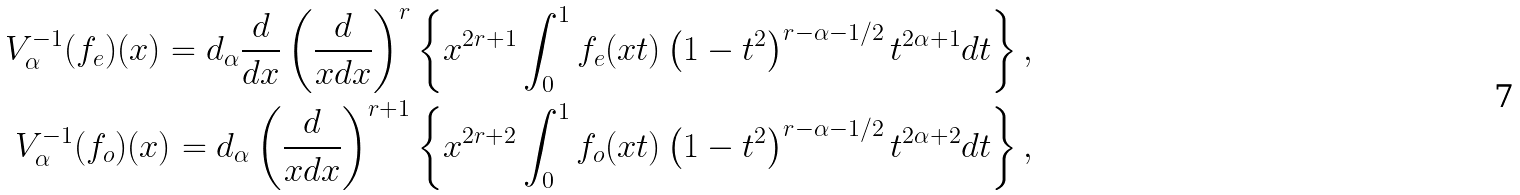<formula> <loc_0><loc_0><loc_500><loc_500>V ^ { - 1 } _ { \alpha } ( f _ { e } ) ( x ) = d _ { \alpha } \frac { d } { d x } \left ( \frac { d } { x d x } \right ) ^ { r } \left \{ x ^ { 2 r + 1 } \int ^ { 1 } _ { 0 } f _ { e } ( x t ) \left ( 1 - t ^ { 2 } \right ) ^ { r - \alpha - 1 / 2 } t ^ { 2 \alpha + 1 } d t \right \} , \\ V ^ { - 1 } _ { \alpha } ( f _ { o } ) ( x ) = d _ { \alpha } \left ( \frac { d } { x d x } \right ) ^ { r + 1 } \left \{ x ^ { 2 r + 2 } \int ^ { 1 } _ { 0 } f _ { o } ( x t ) \left ( 1 - t ^ { 2 } \right ) ^ { r - \alpha - 1 / 2 } t ^ { 2 \alpha + 2 } d t \right \} ,</formula> 